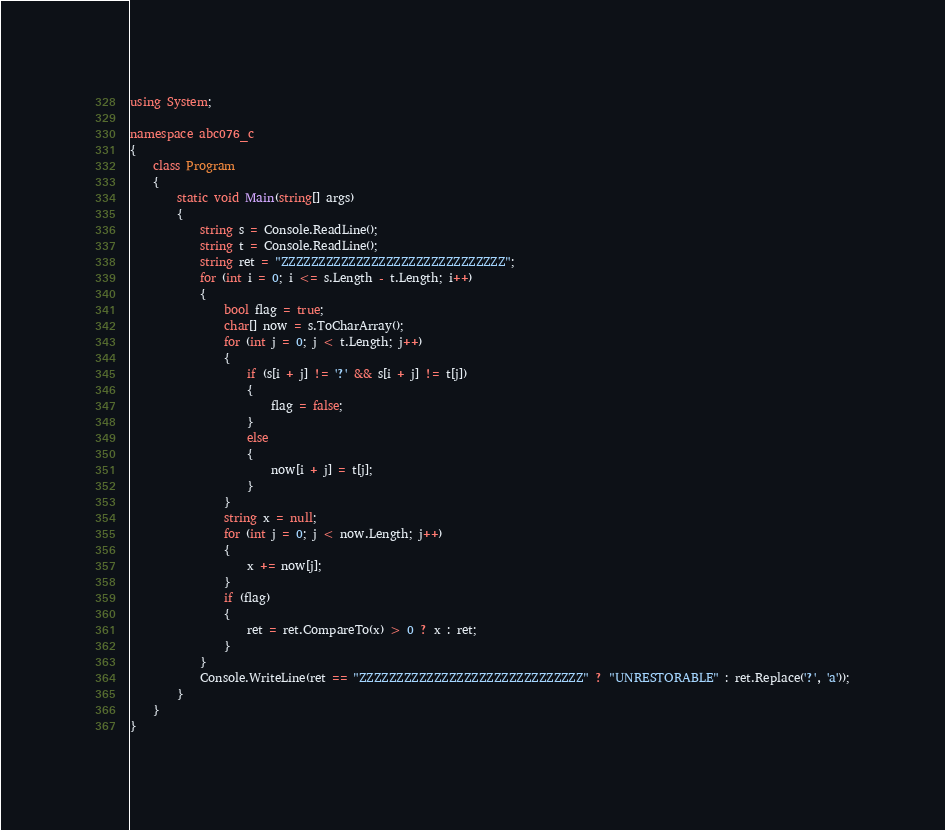<code> <loc_0><loc_0><loc_500><loc_500><_C#_>using System;

namespace abc076_c
{
    class Program
    {
        static void Main(string[] args)
        {
            string s = Console.ReadLine();
            string t = Console.ReadLine();
            string ret = "ZZZZZZZZZZZZZZZZZZZZZZZZZZZZZZ";
            for (int i = 0; i <= s.Length - t.Length; i++)
            {
                bool flag = true;
                char[] now = s.ToCharArray();
                for (int j = 0; j < t.Length; j++)
                {
                    if (s[i + j] != '?' && s[i + j] != t[j])
                    {
                        flag = false;
                    }
                    else
                    {
                        now[i + j] = t[j];
                    }
                }
                string x = null;
                for (int j = 0; j < now.Length; j++)
                {
                    x += now[j];
                }
                if (flag)
                {
                    ret = ret.CompareTo(x) > 0 ? x : ret;
                }
            }
            Console.WriteLine(ret == "ZZZZZZZZZZZZZZZZZZZZZZZZZZZZZZ" ? "UNRESTORABLE" : ret.Replace('?', 'a'));
        }
    }
}</code> 